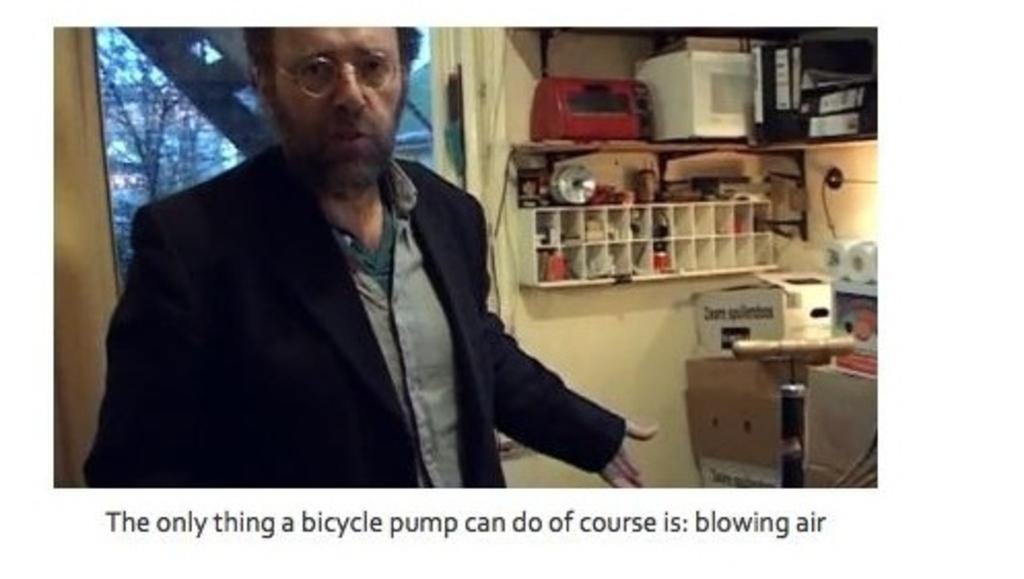Please provide a concise description of this image. In this image we can see a man standing on the floor. In the background we can see objects arranged in cupboards, trees and sky. At the bottom of the image we can see text. 